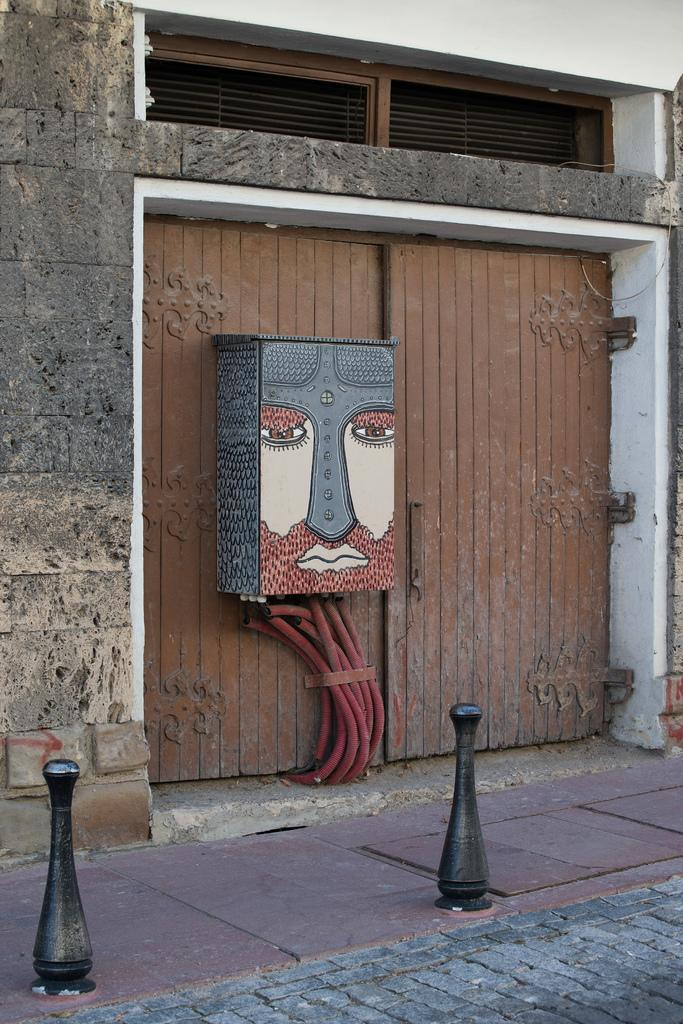What type of door is shown in the image? There is a wooden door in the image. Is there anything attached to the door? Yes, there is a wooden box fixed to the door. What else can be seen in the image besides the door? There is a wall visible in the image. What kind of structure might the image depict? The image appears to depict a building. What is the purpose of the daughter's throat in the image? There is no daughter or throat present in the image. 